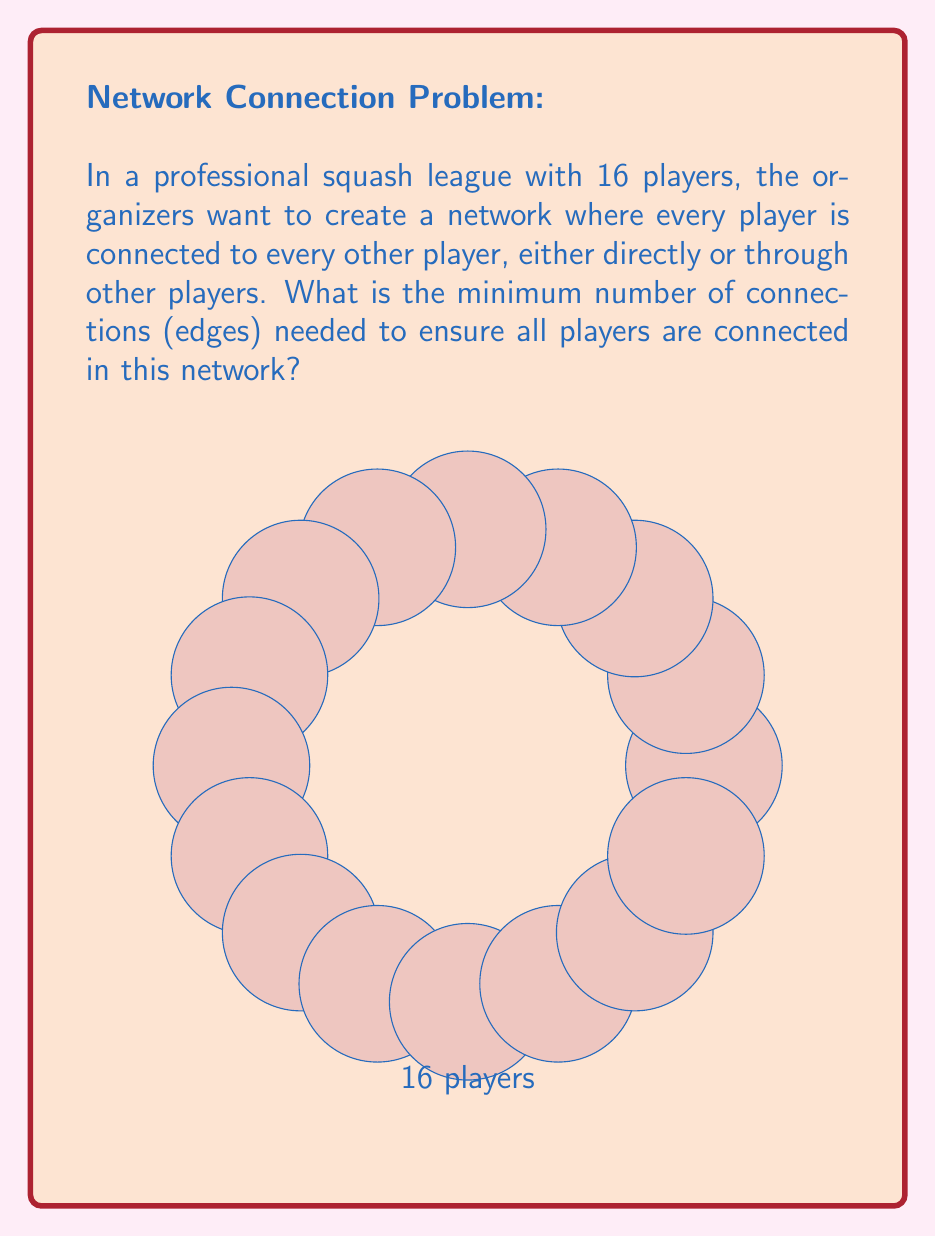Provide a solution to this math problem. To solve this problem, we can use concepts from graph theory:

1) In graph theory, the players represent nodes (vertices) and the connections represent edges.

2) The minimum number of edges needed to connect all nodes in a graph is known as a spanning tree.

3) A key property of a spanning tree is that it has exactly one fewer edge than the number of nodes.

4) This property can be expressed mathematically as:

   $$E_{min} = n - 1$$

   Where $E_{min}$ is the minimum number of edges and $n$ is the number of nodes.

5) In this case, we have 16 players (nodes), so:

   $$E_{min} = 16 - 1 = 15$$

6) Therefore, the minimum number of connections needed is 15.

This solution ensures that all players are connected while using the fewest possible connections. Any fewer connections would result in some players being disconnected from the network.
Answer: 15 connections 